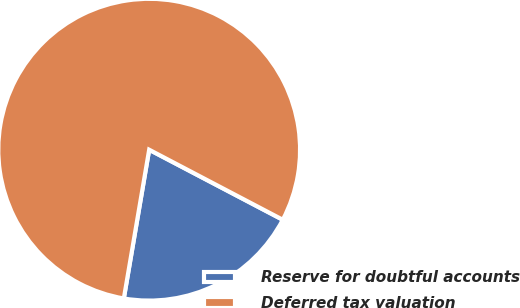<chart> <loc_0><loc_0><loc_500><loc_500><pie_chart><fcel>Reserve for doubtful accounts<fcel>Deferred tax valuation<nl><fcel>20.0%<fcel>80.0%<nl></chart> 